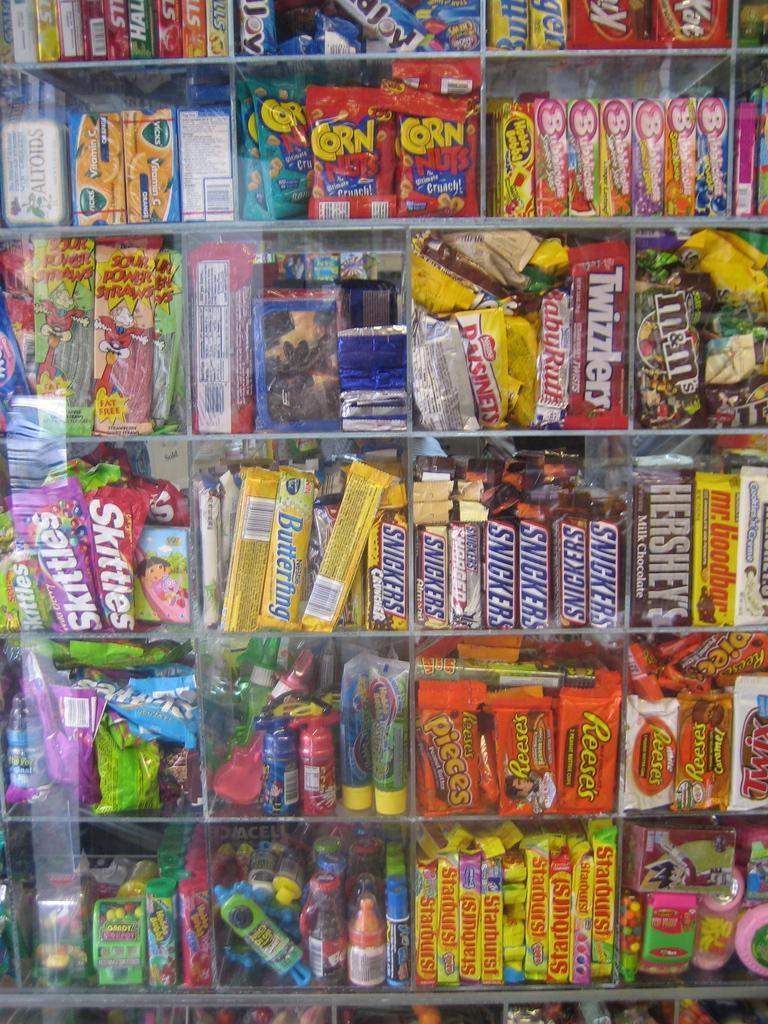<image>
Present a compact description of the photo's key features. A candy display with many different kinds including Snickers, Starbursts, Butterfinger, and Skittles. 